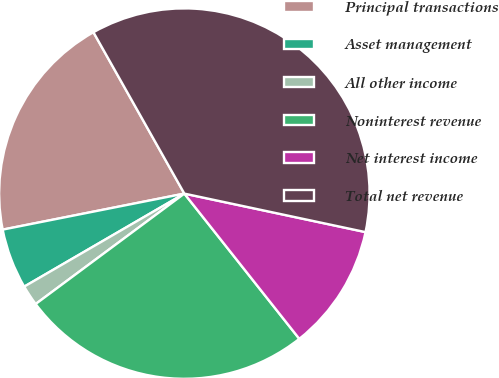Convert chart to OTSL. <chart><loc_0><loc_0><loc_500><loc_500><pie_chart><fcel>Principal transactions<fcel>Asset management<fcel>All other income<fcel>Noninterest revenue<fcel>Net interest income<fcel>Total net revenue<nl><fcel>19.95%<fcel>5.26%<fcel>1.79%<fcel>25.49%<fcel>11.01%<fcel>36.5%<nl></chart> 